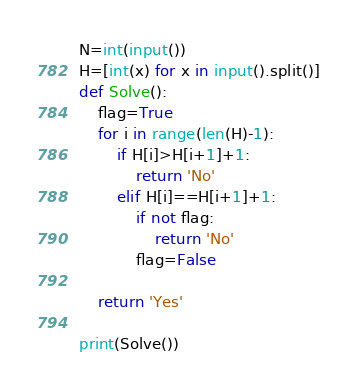Convert code to text. <code><loc_0><loc_0><loc_500><loc_500><_Python_>N=int(input())
H=[int(x) for x in input().split()]
def Solve():
    flag=True
    for i in range(len(H)-1):
        if H[i]>H[i+1]+1:
            return 'No'
        elif H[i]==H[i+1]+1:
            if not flag:
                return 'No'
            flag=False
                
    return 'Yes'

print(Solve())            
</code> 